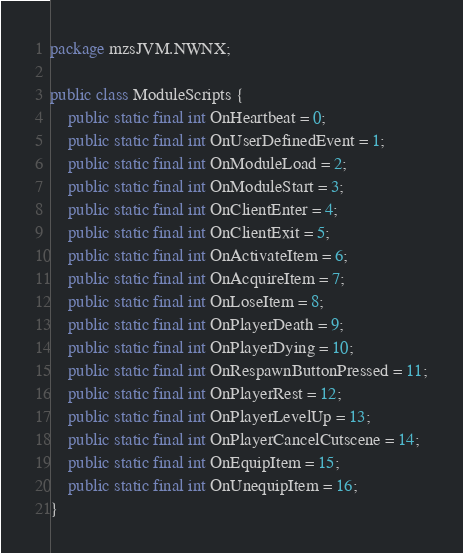<code> <loc_0><loc_0><loc_500><loc_500><_Java_>package mzsJVM.NWNX;

public class ModuleScripts {
    public static final int OnHeartbeat = 0;
    public static final int OnUserDefinedEvent = 1;
    public static final int OnModuleLoad = 2;
    public static final int OnModuleStart = 3;
    public static final int OnClientEnter = 4;
    public static final int OnClientExit = 5;
    public static final int OnActivateItem = 6;
    public static final int OnAcquireItem = 7;
    public static final int OnLoseItem = 8;
    public static final int OnPlayerDeath = 9;
    public static final int OnPlayerDying = 10;
    public static final int OnRespawnButtonPressed = 11;
    public static final int OnPlayerRest = 12;
    public static final int OnPlayerLevelUp = 13;
    public static final int OnPlayerCancelCutscene = 14;
    public static final int OnEquipItem = 15;
    public static final int OnUnequipItem = 16;
}
</code> 